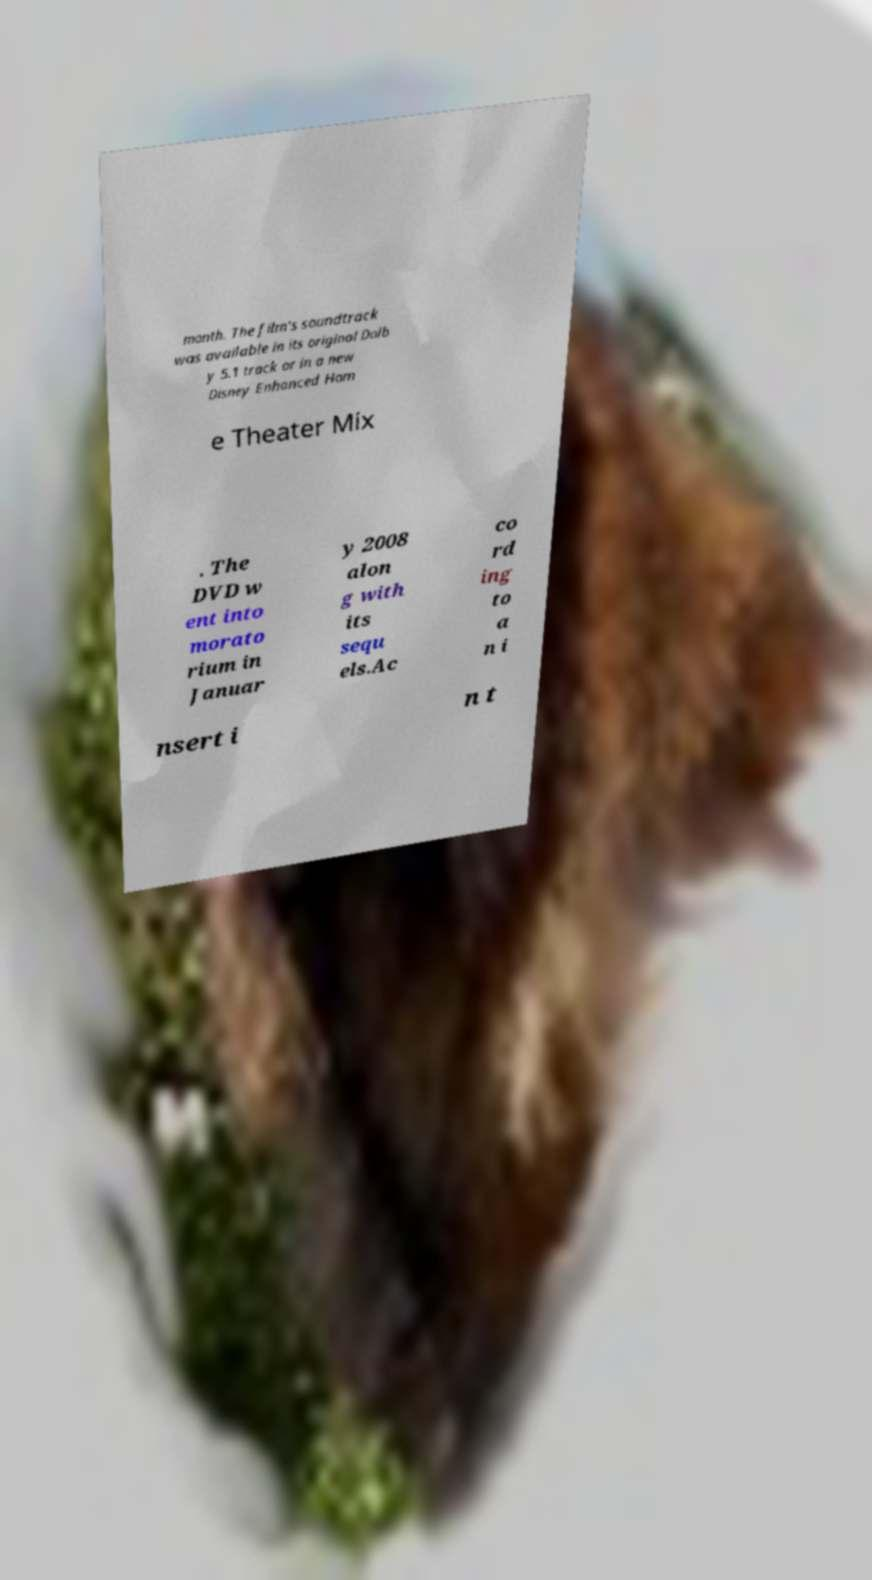Could you assist in decoding the text presented in this image and type it out clearly? month. The film's soundtrack was available in its original Dolb y 5.1 track or in a new Disney Enhanced Hom e Theater Mix . The DVD w ent into morato rium in Januar y 2008 alon g with its sequ els.Ac co rd ing to a n i nsert i n t 